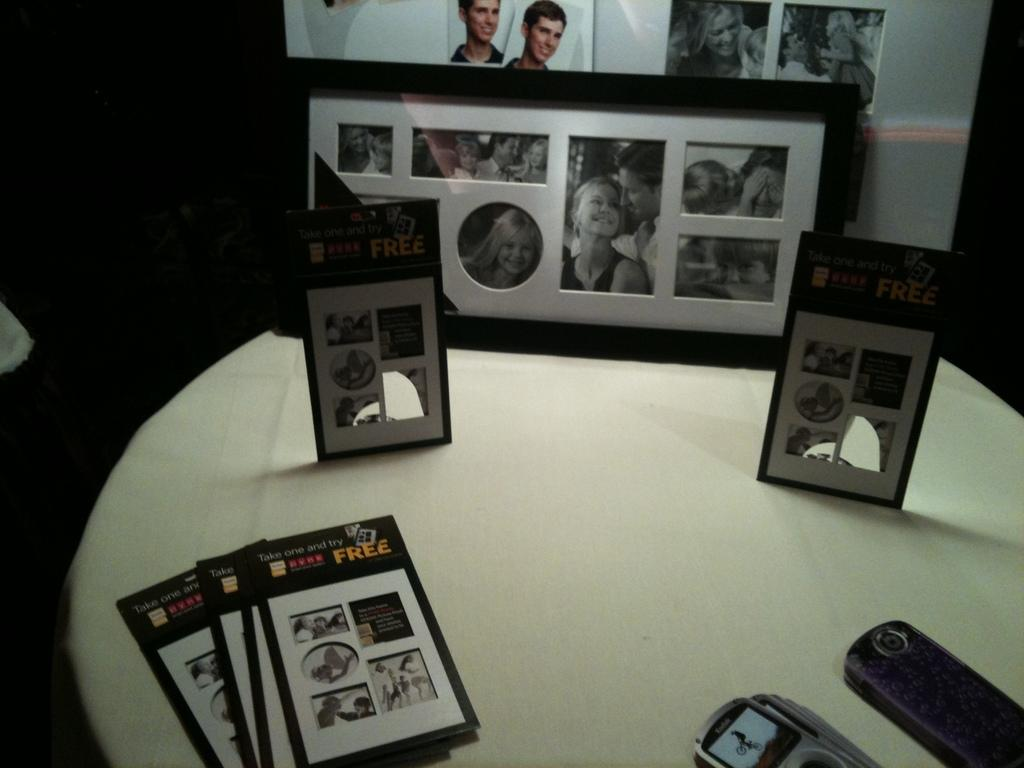Provide a one-sentence caption for the provided image. A stack of cards says that people can take one and try for free. 